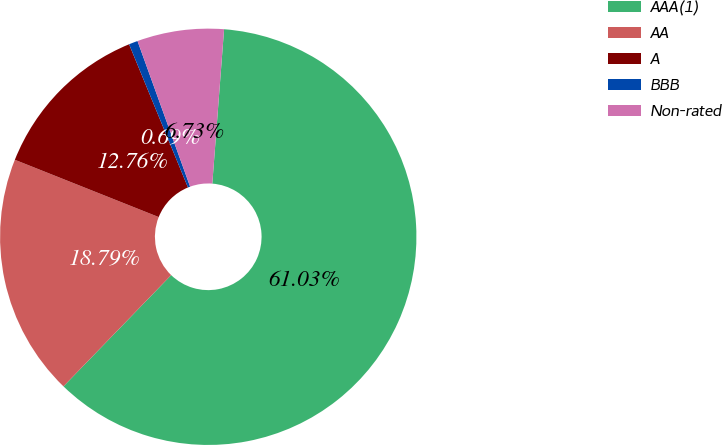<chart> <loc_0><loc_0><loc_500><loc_500><pie_chart><fcel>AAA(1)<fcel>AA<fcel>A<fcel>BBB<fcel>Non-rated<nl><fcel>61.03%<fcel>18.79%<fcel>12.76%<fcel>0.69%<fcel>6.73%<nl></chart> 